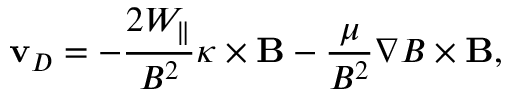Convert formula to latex. <formula><loc_0><loc_0><loc_500><loc_500>v _ { D } = - \frac { 2 W _ { \| } } { B ^ { 2 } } \kappa \times B - \frac { \mu } { B ^ { 2 } } \nabla B \times B ,</formula> 